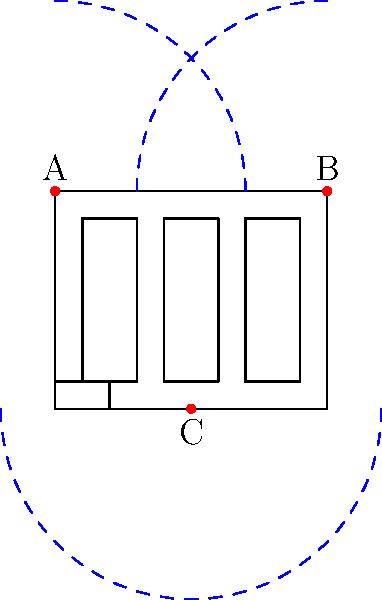Given the floor plan of a convenience store with three CCTV cameras (A, B, and C) placed as shown, which camera should be adjusted or relocated to maximize coverage and minimize blind spots? Assume each camera has a 90-degree field of view and a range of 7 units. To analyze the CCTV camera placement and determine which camera should be adjusted, we'll follow these steps:

1. Evaluate the current coverage:
   Camera A (top-left): Covers the left side and part of the center.
   Camera B (top-right): Covers the right side and part of the center.
   Camera C (bottom-center): Covers the entire bottom half and center.

2. Identify blind spots:
   The main blind spots are in the corners, especially the top-center area between shelves.

3. Assess each camera's effectiveness:
   Camera A and B provide good coverage of the sides and top of the store.
   Camera C covers a large area, including the counter and entrance.

4. Determine the best candidate for adjustment:
   Camera C is the best candidate for adjustment because:
   a. It has the most overlap with the other cameras.
   b. Its current position leaves significant blind spots in the upper center.
   c. Moving it could potentially cover the blind spots without sacrificing much of its current coverage.

5. Propose an adjustment:
   Moving Camera C to the center of the ceiling (5,4) would:
   a. Maintain coverage of the counter and entrance.
   b. Reduce overlap with Cameras A and B.
   c. Provide better coverage of the central area between shelves.
   d. Minimize blind spots in the store's layout.

This adjustment would result in a more even distribution of coverage throughout the store, maximizing security effectiveness.
Answer: Camera C should be relocated to the center of the ceiling (5,4). 